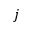Convert formula to latex. <formula><loc_0><loc_0><loc_500><loc_500>j</formula> 